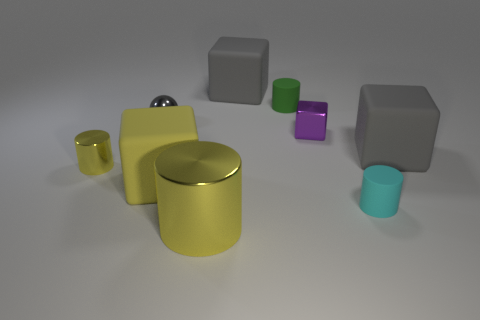What number of other things are the same color as the ball?
Your response must be concise. 2. How many big things are in front of the tiny yellow thing and behind the tiny cyan rubber cylinder?
Make the answer very short. 1. The tiny gray shiny object has what shape?
Your answer should be compact. Sphere. How many other things are there of the same material as the small purple block?
Keep it short and to the point. 3. There is a metallic cylinder in front of the yellow shiny object left of the yellow metal object that is to the right of the tiny yellow cylinder; what color is it?
Keep it short and to the point. Yellow. There is a gray ball that is the same size as the purple metallic object; what is its material?
Keep it short and to the point. Metal. How many objects are either big things behind the small green thing or brown shiny balls?
Keep it short and to the point. 1. Are there any green objects?
Your response must be concise. Yes. What is the tiny cyan thing that is in front of the small shiny cube made of?
Your response must be concise. Rubber. There is a large block that is the same color as the tiny shiny cylinder; what is its material?
Make the answer very short. Rubber. 